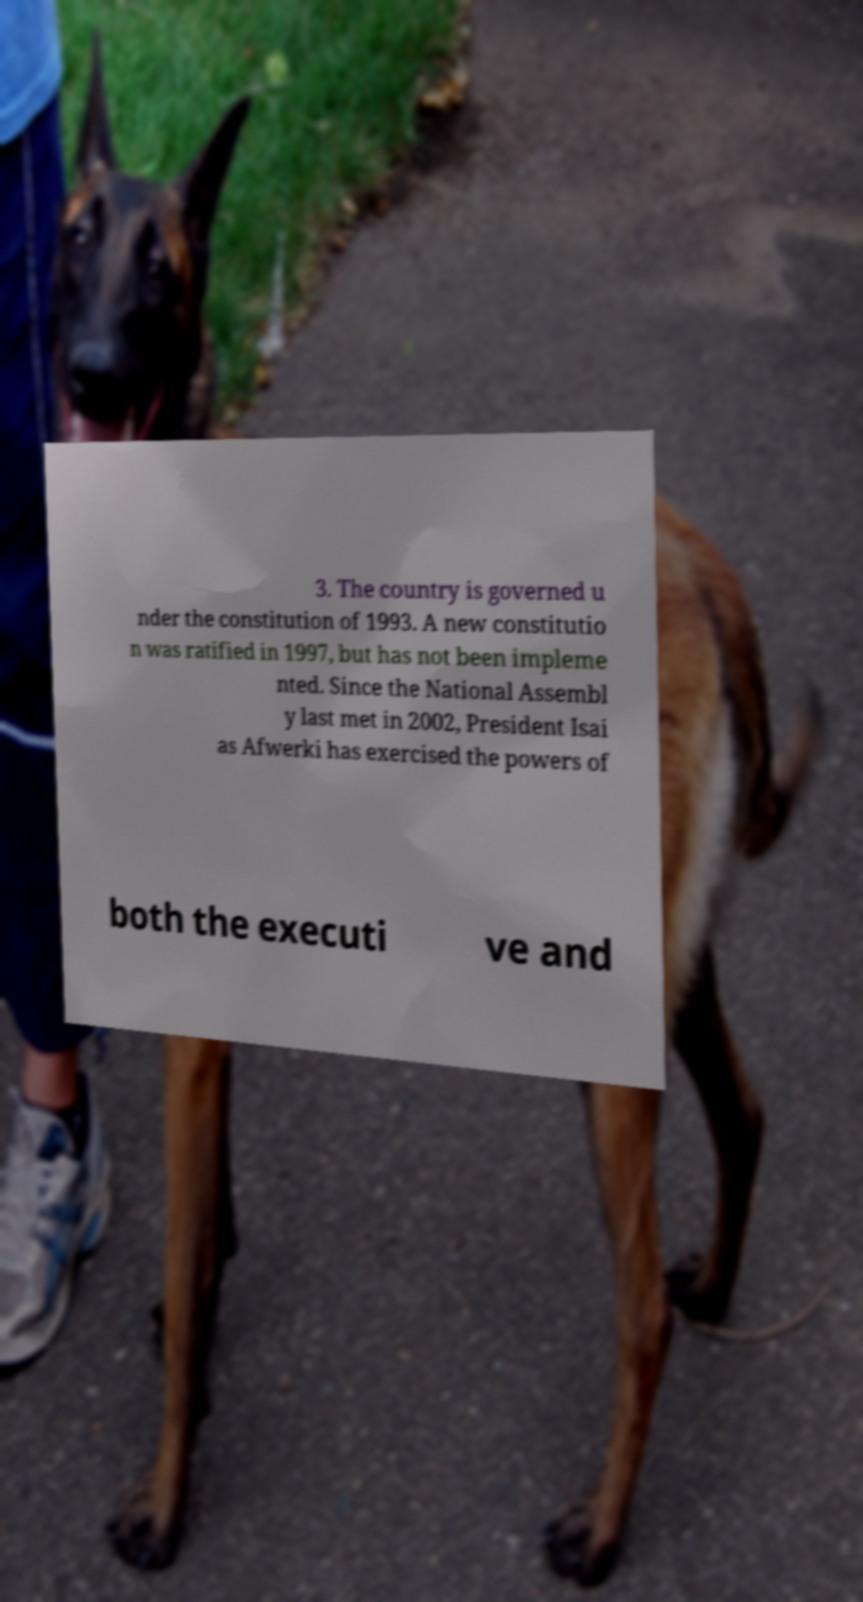Could you extract and type out the text from this image? 3. The country is governed u nder the constitution of 1993. A new constitutio n was ratified in 1997, but has not been impleme nted. Since the National Assembl y last met in 2002, President Isai as Afwerki has exercised the powers of both the executi ve and 